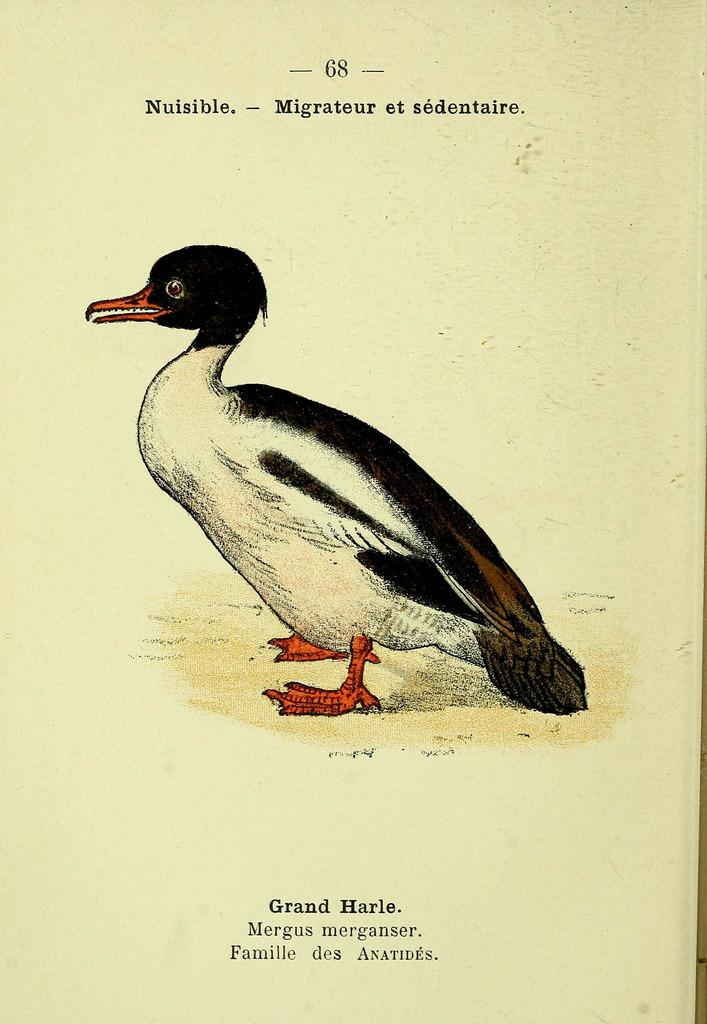What is depicted in the image? There is a picture of a duck in the image. Are there any words or letters in the image? Yes, there is text in the image. What is the medium of the image? The image appears to be on a piece of paper. What type of string is being used by the duck in the image? There is no string present in the image, and the duck is not shown using any string. 